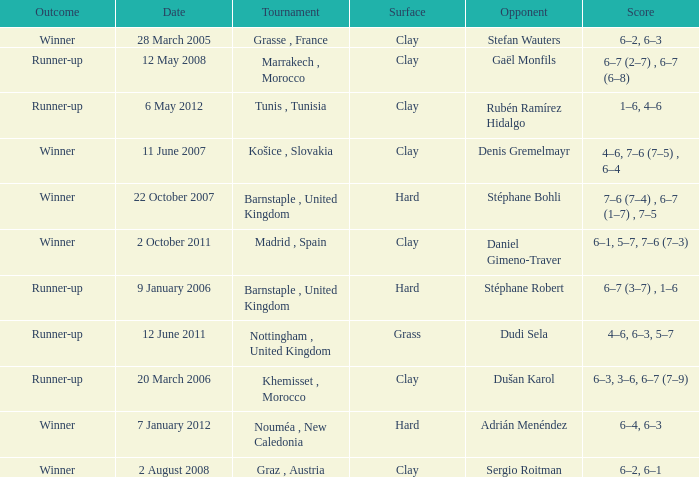What is the score on 2 October 2011? 6–1, 5–7, 7–6 (7–3). 